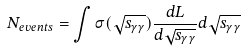<formula> <loc_0><loc_0><loc_500><loc_500>N _ { e v e n t s } = \int \sigma ( \sqrt { s _ { \gamma \gamma } } ) \frac { d L } { d \sqrt { s _ { \gamma \gamma } } } d \sqrt { s _ { \gamma \gamma } }</formula> 